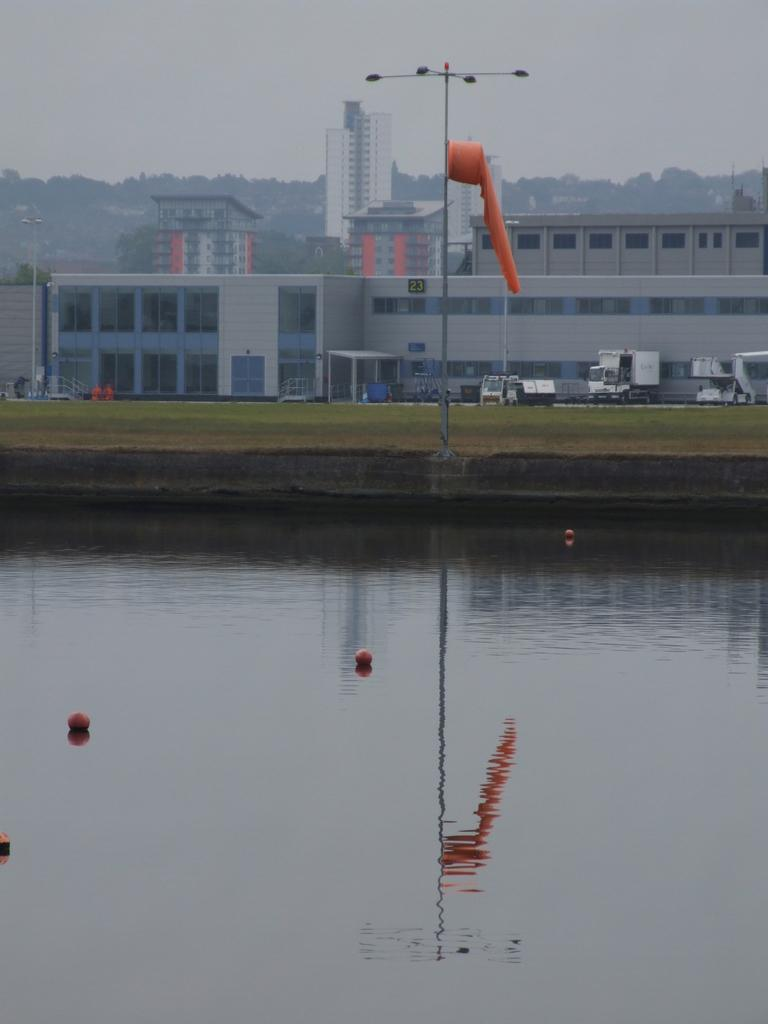What is on the water in the image? There are objects on the water in the image. What can be seen in the image besides the objects on the water? There are lights, an object on a pole, buildings, vehicles, windows, trees, and the sky visible in the image. What type of veil is draped over the land in the image? There is no veil present in the image. 